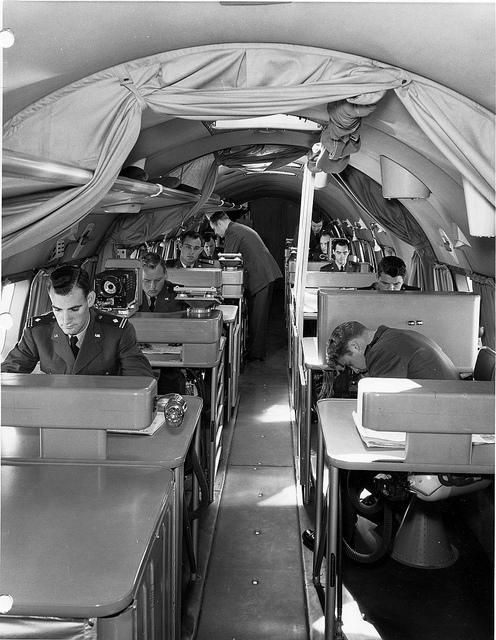Are they in a plane?
Answer briefly. Yes. Where are the men sitting?
Give a very brief answer. Airplane. These are probably WWI soldiers?
Keep it brief. Yes. 